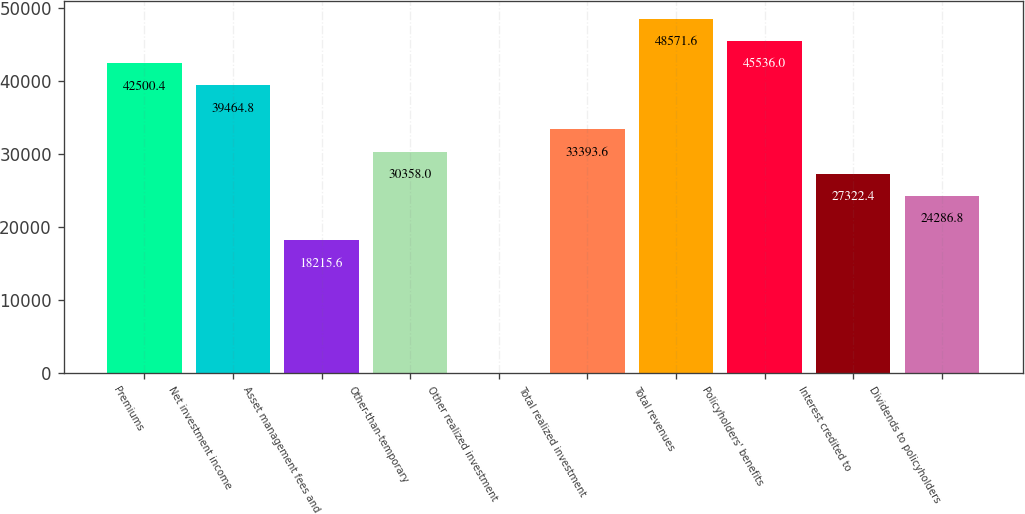<chart> <loc_0><loc_0><loc_500><loc_500><bar_chart><fcel>Premiums<fcel>Net investment income<fcel>Asset management fees and<fcel>Other-than-temporary<fcel>Other realized investment<fcel>Total realized investment<fcel>Total revenues<fcel>Policyholders' benefits<fcel>Interest credited to<fcel>Dividends to policyholders<nl><fcel>42500.4<fcel>39464.8<fcel>18215.6<fcel>30358<fcel>2<fcel>33393.6<fcel>48571.6<fcel>45536<fcel>27322.4<fcel>24286.8<nl></chart> 